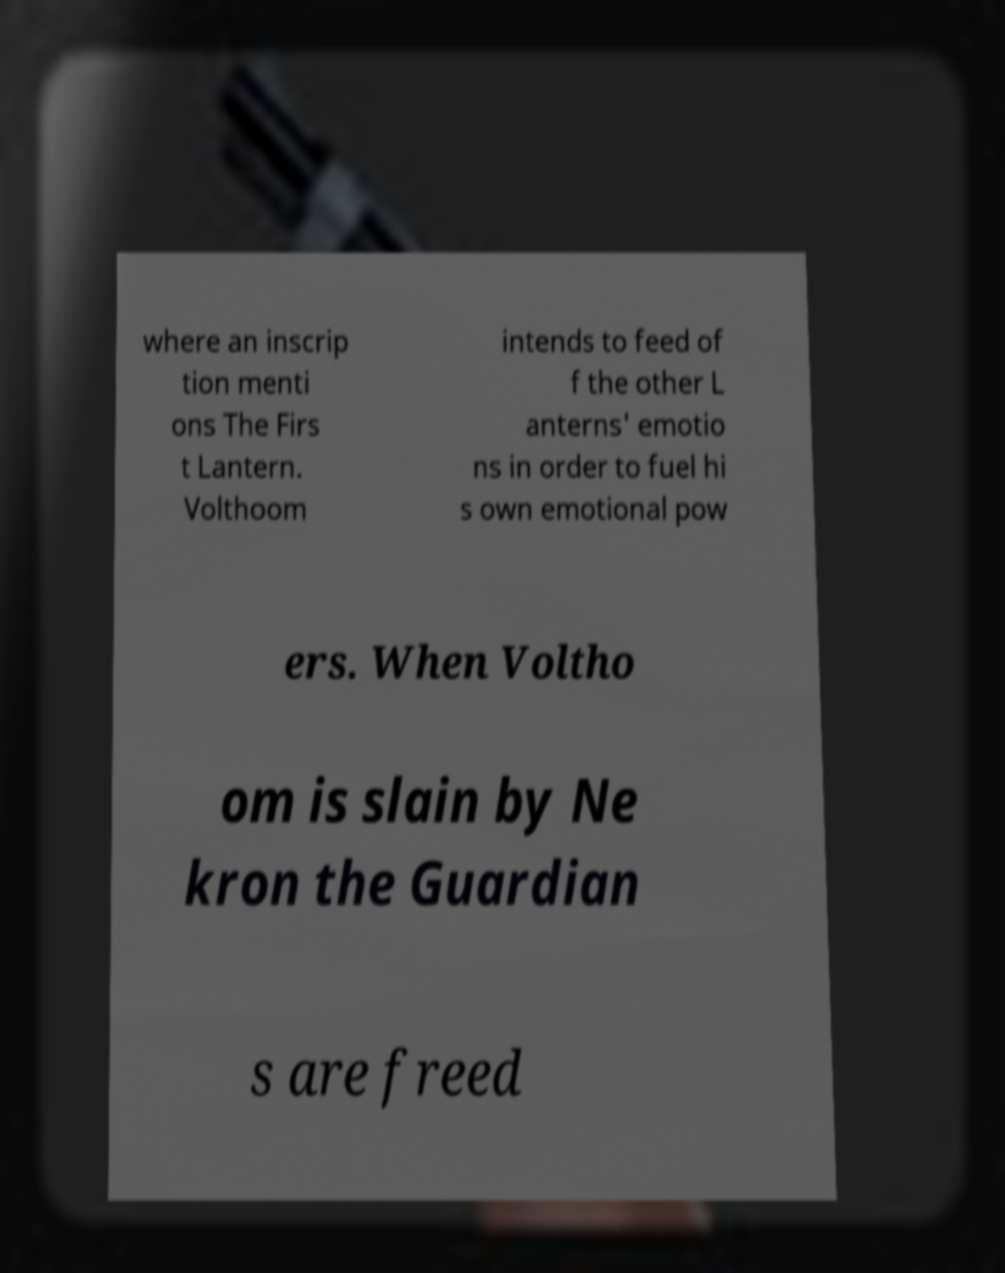Could you assist in decoding the text presented in this image and type it out clearly? where an inscrip tion menti ons The Firs t Lantern. Volthoom intends to feed of f the other L anterns' emotio ns in order to fuel hi s own emotional pow ers. When Voltho om is slain by Ne kron the Guardian s are freed 